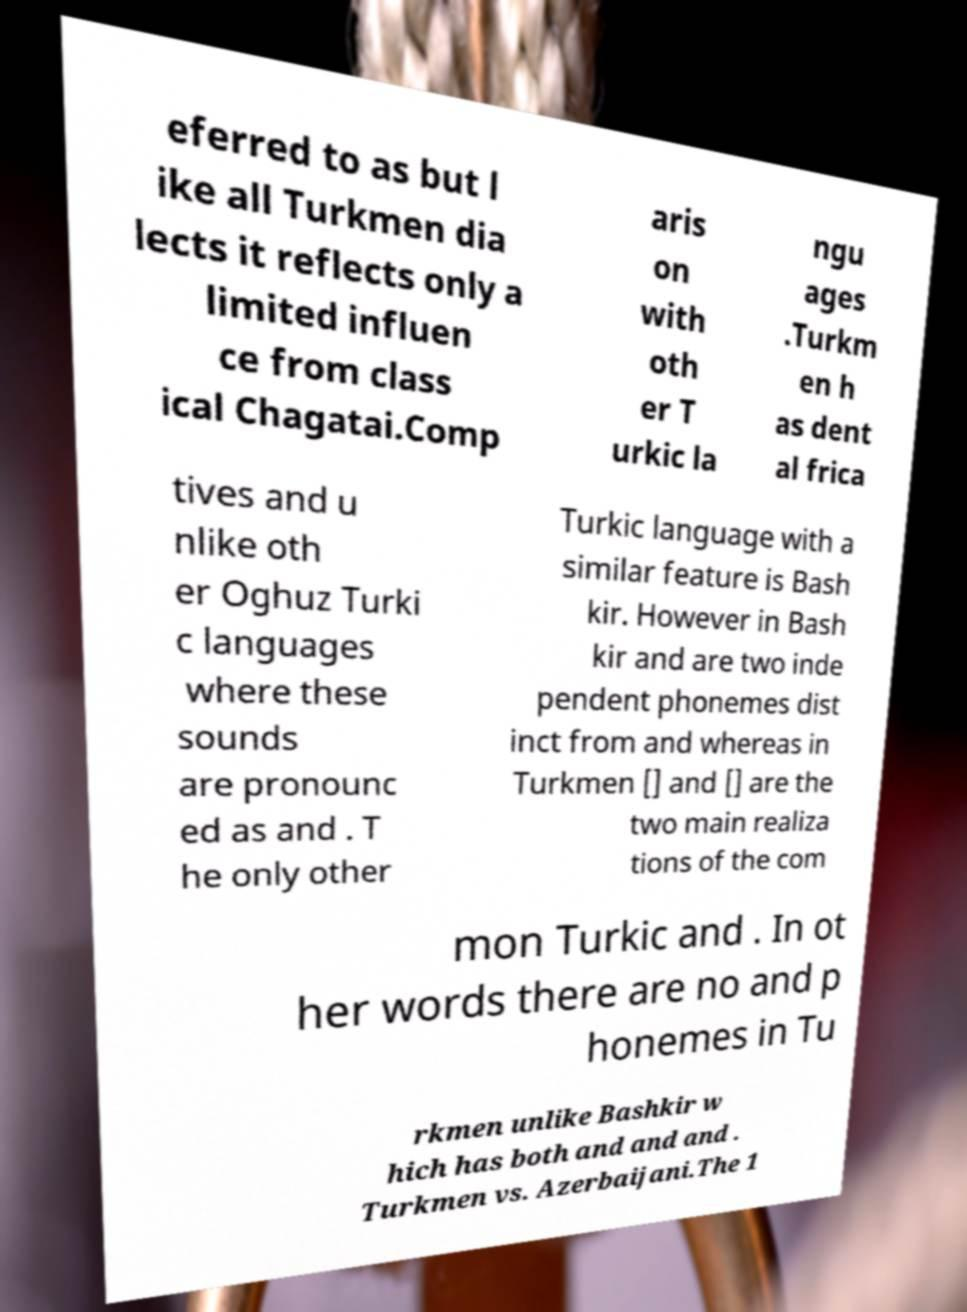What messages or text are displayed in this image? I need them in a readable, typed format. eferred to as but l ike all Turkmen dia lects it reflects only a limited influen ce from class ical Chagatai.Comp aris on with oth er T urkic la ngu ages .Turkm en h as dent al frica tives and u nlike oth er Oghuz Turki c languages where these sounds are pronounc ed as and . T he only other Turkic language with a similar feature is Bash kir. However in Bash kir and are two inde pendent phonemes dist inct from and whereas in Turkmen [] and [] are the two main realiza tions of the com mon Turkic and . In ot her words there are no and p honemes in Tu rkmen unlike Bashkir w hich has both and and and . Turkmen vs. Azerbaijani.The 1 